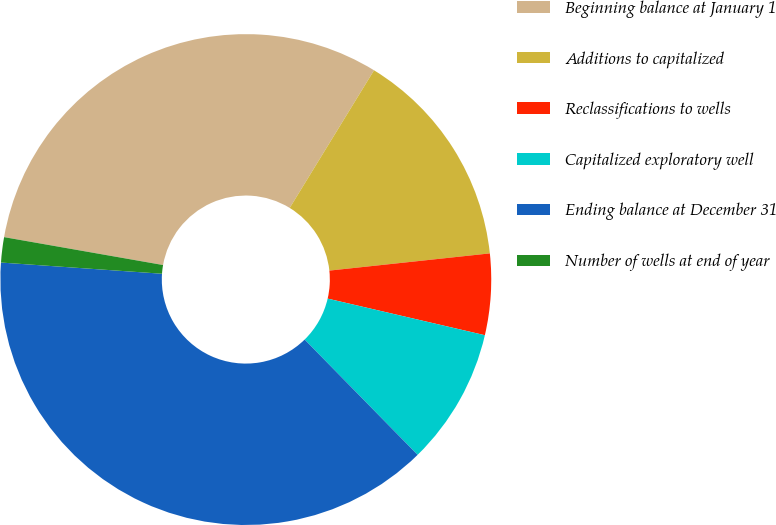Convert chart to OTSL. <chart><loc_0><loc_0><loc_500><loc_500><pie_chart><fcel>Beginning balance at January 1<fcel>Additions to capitalized<fcel>Reclassifications to wells<fcel>Capitalized exploratory well<fcel>Ending balance at December 31<fcel>Number of wells at end of year<nl><fcel>30.98%<fcel>14.55%<fcel>5.34%<fcel>9.02%<fcel>38.44%<fcel>1.66%<nl></chart> 